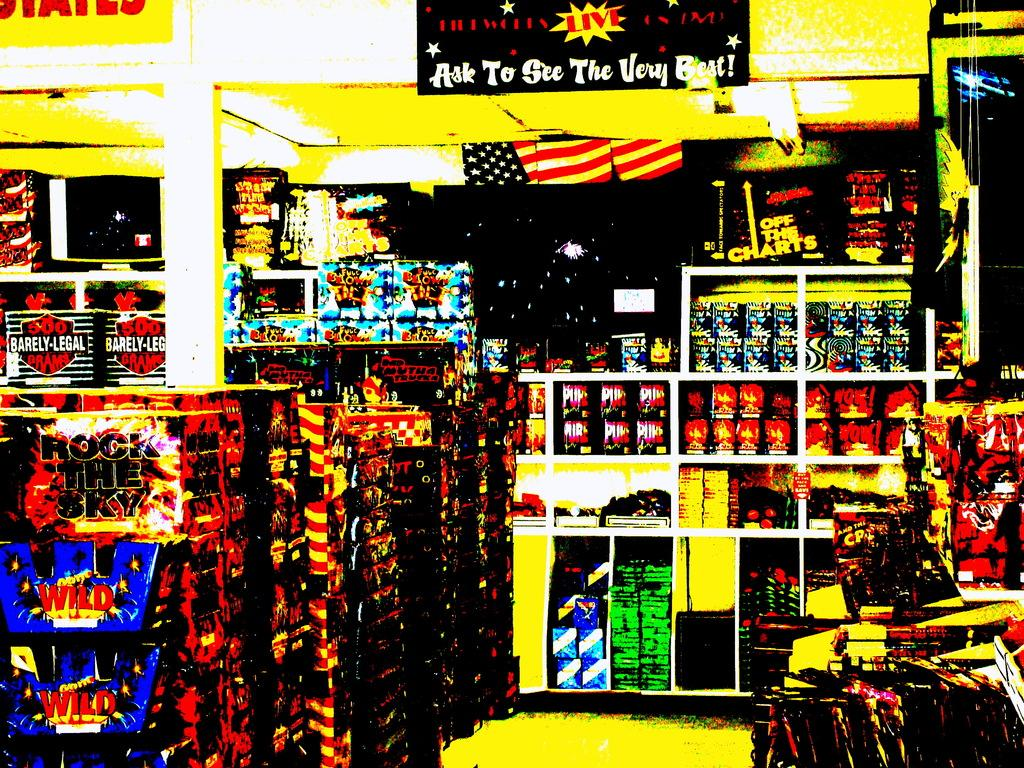Provide a one-sentence caption for the provided image. The interior of a store has a banner that says "ask to see the very best!". 